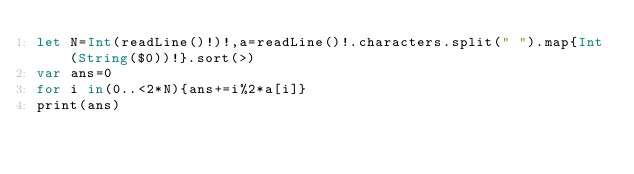<code> <loc_0><loc_0><loc_500><loc_500><_Swift_>let N=Int(readLine()!)!,a=readLine()!.characters.split(" ").map{Int(String($0))!}.sort(>)
var ans=0
for i in(0..<2*N){ans+=i%2*a[i]}
print(ans)</code> 